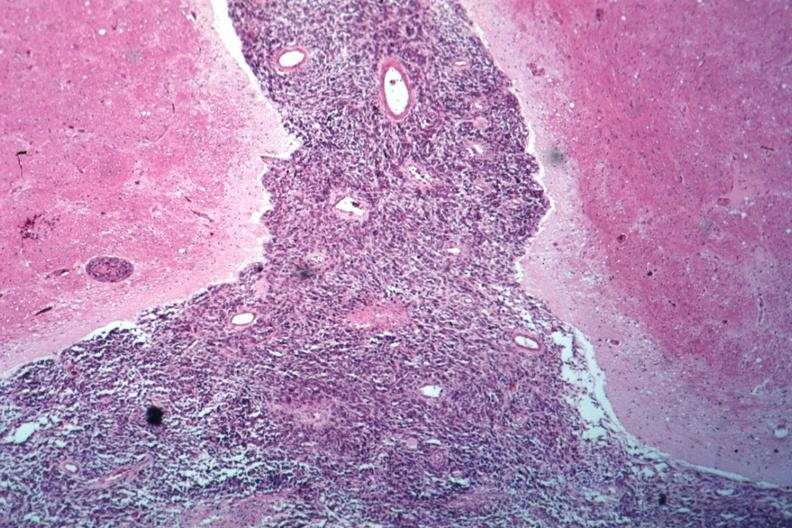what does this image show?
Answer the question using a single word or phrase. Looks like spindle cell tumor filling space well shown primary not known at time 